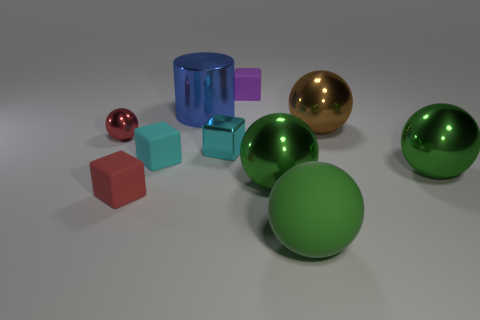What might be the purpose of this assortment of objects? This image may serve several purposes such as being a visual aid for discussions about geometry, colors, and materials in a learning context. Alternatively, it could be an artistic composition aiming to showcase contrasts in color and texture, or a scene from a computer graphics test render, demonstrating rendering capabilities of different surface qualities and lighting effects.  Are there any patterns or alignments in how the objects are presented? Interestingly, while the overall arrangement initially appears random, upon closer inspection, there might be an intent to demonstrate certain principles of depth and perspective. For instance, the larger objects are generally placed further back, adding a sense of depth to the image. Additionally, the varied spacing between the objects presents an opportunity to observe shadows and highlights, thereby enhancing the perception of three-dimensional form. 